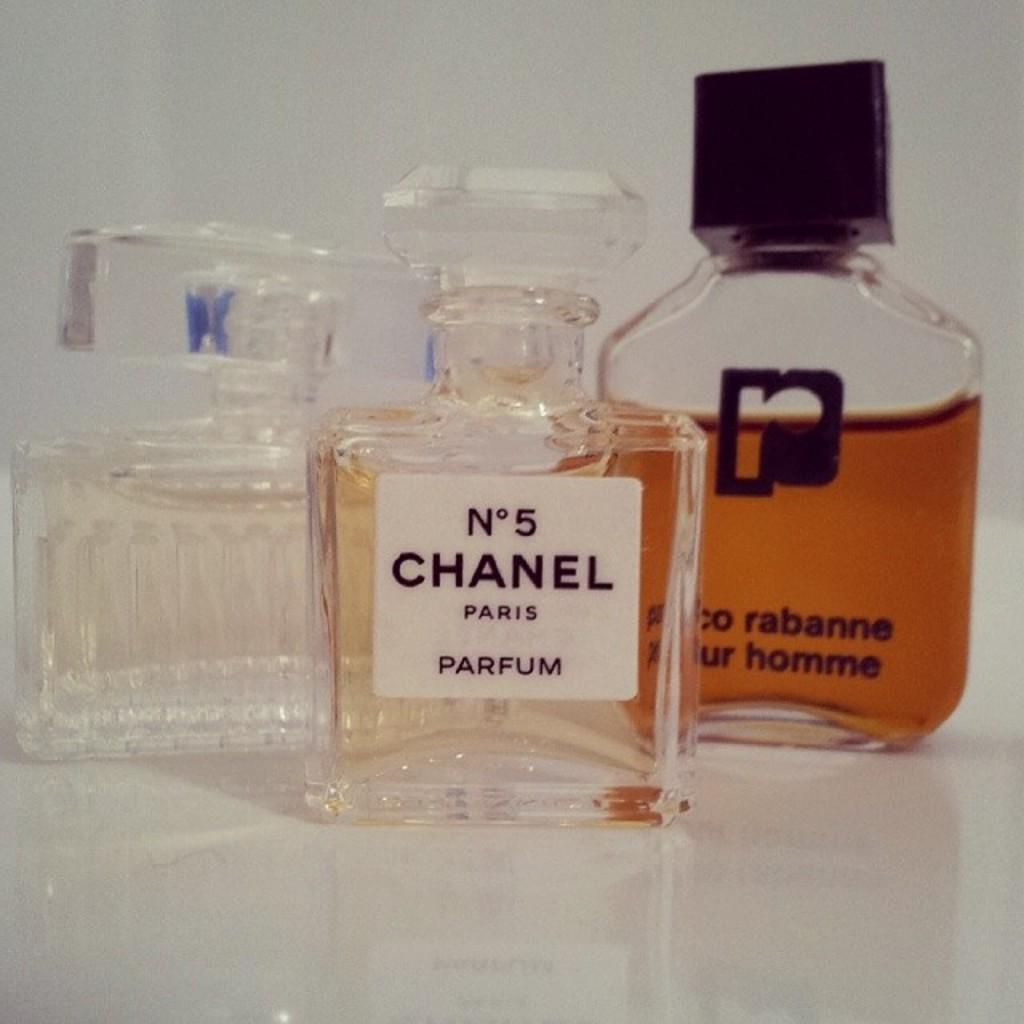<image>
Render a clear and concise summary of the photo. Three perfume bottles, one being Chanel number 5, are next to each other. 